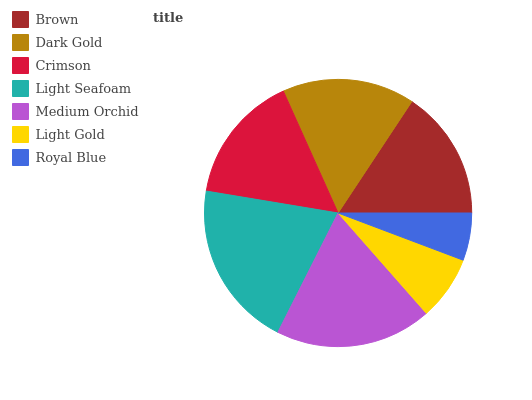Is Royal Blue the minimum?
Answer yes or no. Yes. Is Light Seafoam the maximum?
Answer yes or no. Yes. Is Dark Gold the minimum?
Answer yes or no. No. Is Dark Gold the maximum?
Answer yes or no. No. Is Dark Gold greater than Brown?
Answer yes or no. Yes. Is Brown less than Dark Gold?
Answer yes or no. Yes. Is Brown greater than Dark Gold?
Answer yes or no. No. Is Dark Gold less than Brown?
Answer yes or no. No. Is Brown the high median?
Answer yes or no. Yes. Is Brown the low median?
Answer yes or no. Yes. Is Medium Orchid the high median?
Answer yes or no. No. Is Dark Gold the low median?
Answer yes or no. No. 